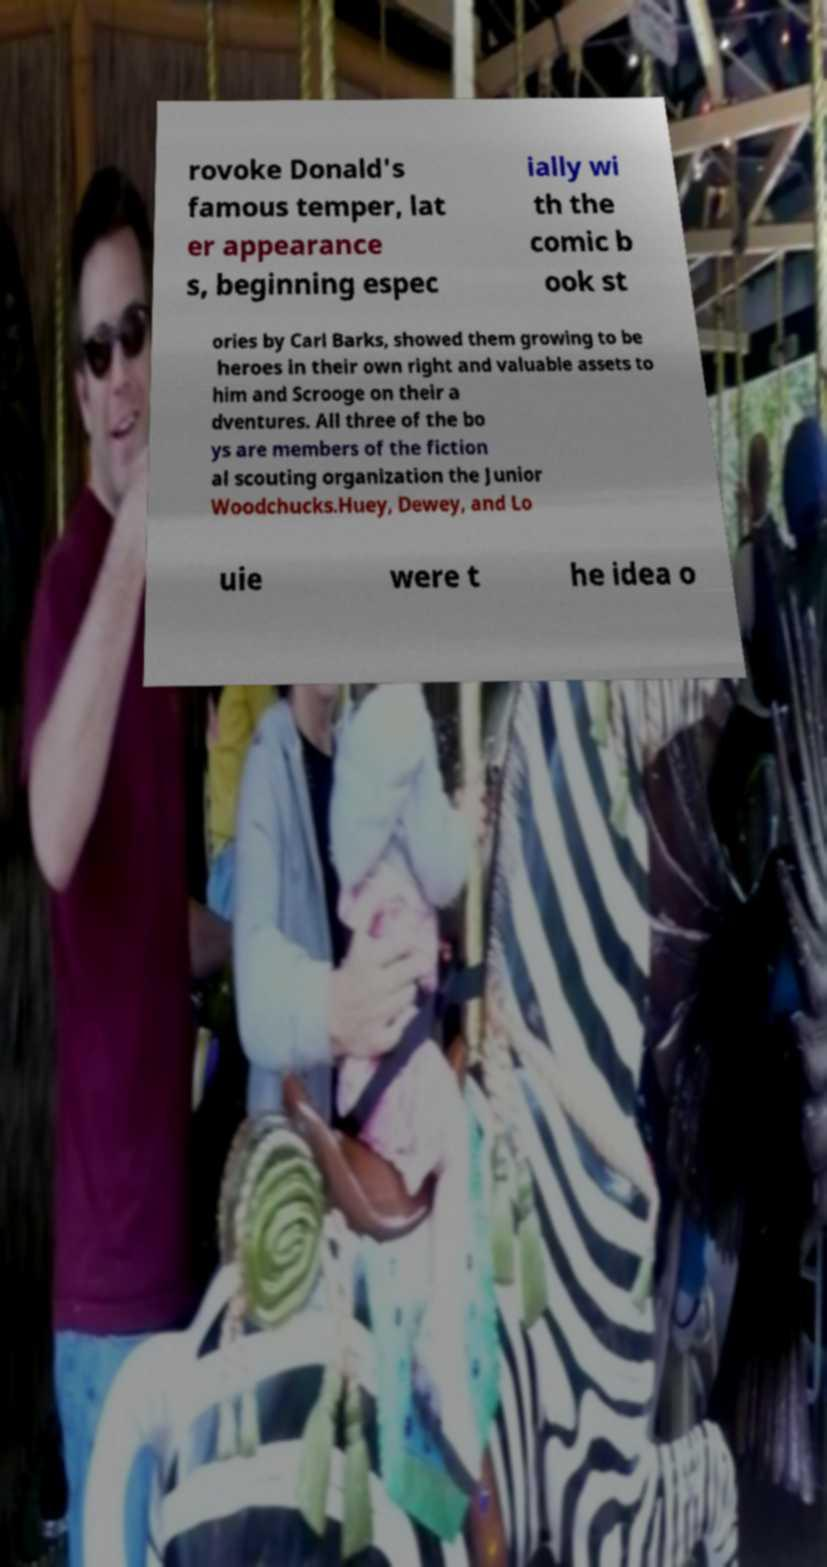What messages or text are displayed in this image? I need them in a readable, typed format. rovoke Donald's famous temper, lat er appearance s, beginning espec ially wi th the comic b ook st ories by Carl Barks, showed them growing to be heroes in their own right and valuable assets to him and Scrooge on their a dventures. All three of the bo ys are members of the fiction al scouting organization the Junior Woodchucks.Huey, Dewey, and Lo uie were t he idea o 